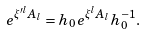<formula> <loc_0><loc_0><loc_500><loc_500>e ^ { \xi ^ { \prime l } { A } _ { l } } = h _ { 0 } e ^ { \xi ^ { l } { A } _ { l } } h _ { 0 } ^ { - 1 } .</formula> 